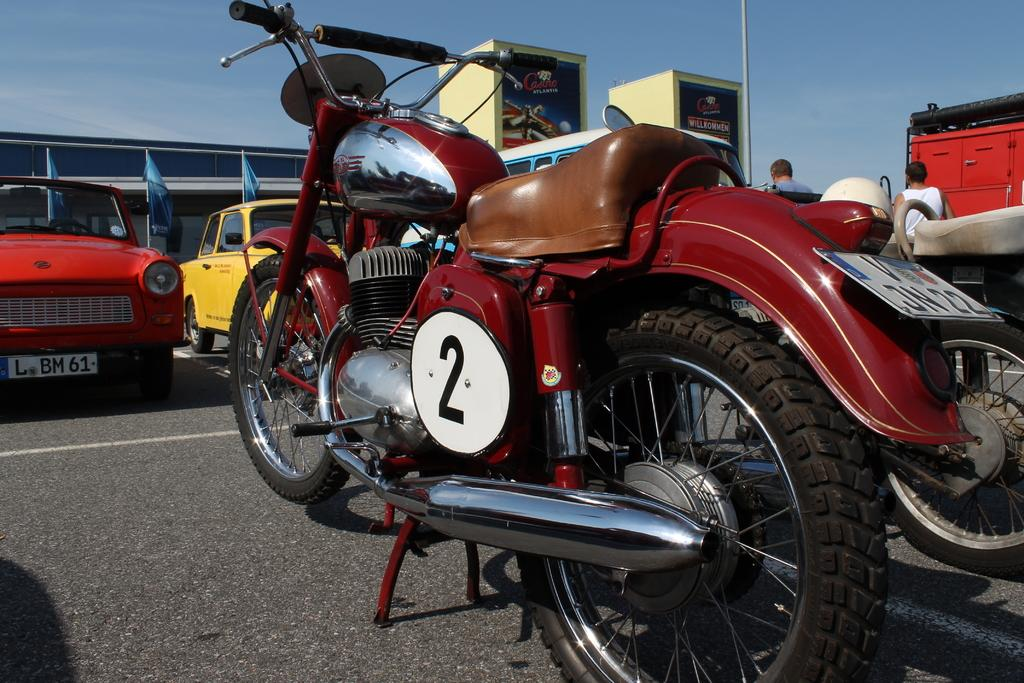<image>
Summarize the visual content of the image. A red motorcycle with the number 2 is parked among old cars. 